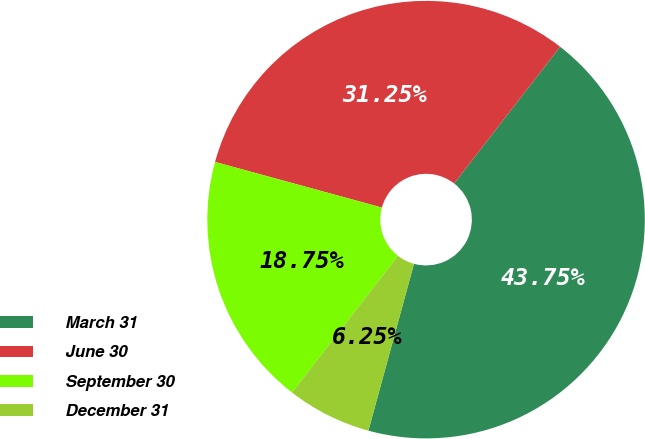Convert chart. <chart><loc_0><loc_0><loc_500><loc_500><pie_chart><fcel>March 31<fcel>June 30<fcel>September 30<fcel>December 31<nl><fcel>43.75%<fcel>31.25%<fcel>18.75%<fcel>6.25%<nl></chart> 